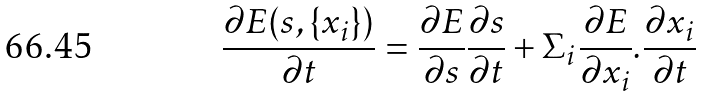<formula> <loc_0><loc_0><loc_500><loc_500>\frac { \partial E ( s , \{ x _ { i } \} ) } { \partial t } = \frac { \partial E } { \partial s } \frac { \partial s } { \partial t } + \Sigma _ { i } \frac { \partial E } { \partial x _ { i } } . \frac { \partial x _ { i } } { \partial t }</formula> 